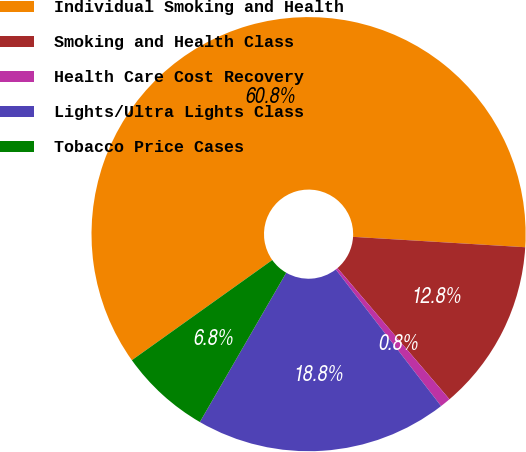<chart> <loc_0><loc_0><loc_500><loc_500><pie_chart><fcel>Individual Smoking and Health<fcel>Smoking and Health Class<fcel>Health Care Cost Recovery<fcel>Lights/Ultra Lights Class<fcel>Tobacco Price Cases<nl><fcel>60.82%<fcel>12.8%<fcel>0.79%<fcel>18.8%<fcel>6.79%<nl></chart> 